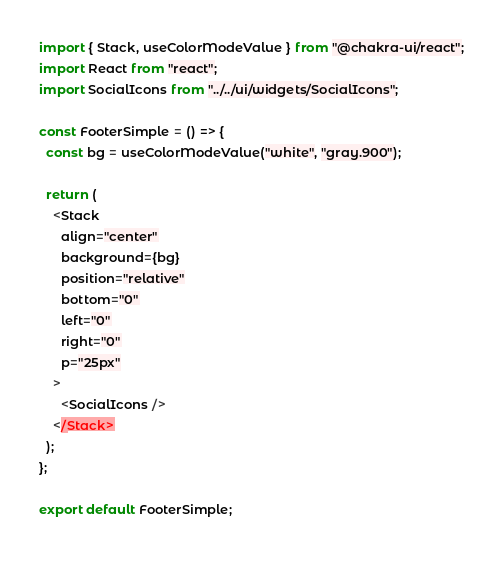Convert code to text. <code><loc_0><loc_0><loc_500><loc_500><_TypeScript_>import { Stack, useColorModeValue } from "@chakra-ui/react";
import React from "react";
import SocialIcons from "../../ui/widgets/SocialIcons";

const FooterSimple = () => {
  const bg = useColorModeValue("white", "gray.900");

  return (
    <Stack
      align="center"
      background={bg}
      position="relative"
      bottom="0"
      left="0"
      right="0"
      p="25px"
    >
      <SocialIcons />
    </Stack>
  );
};

export default FooterSimple;
</code> 